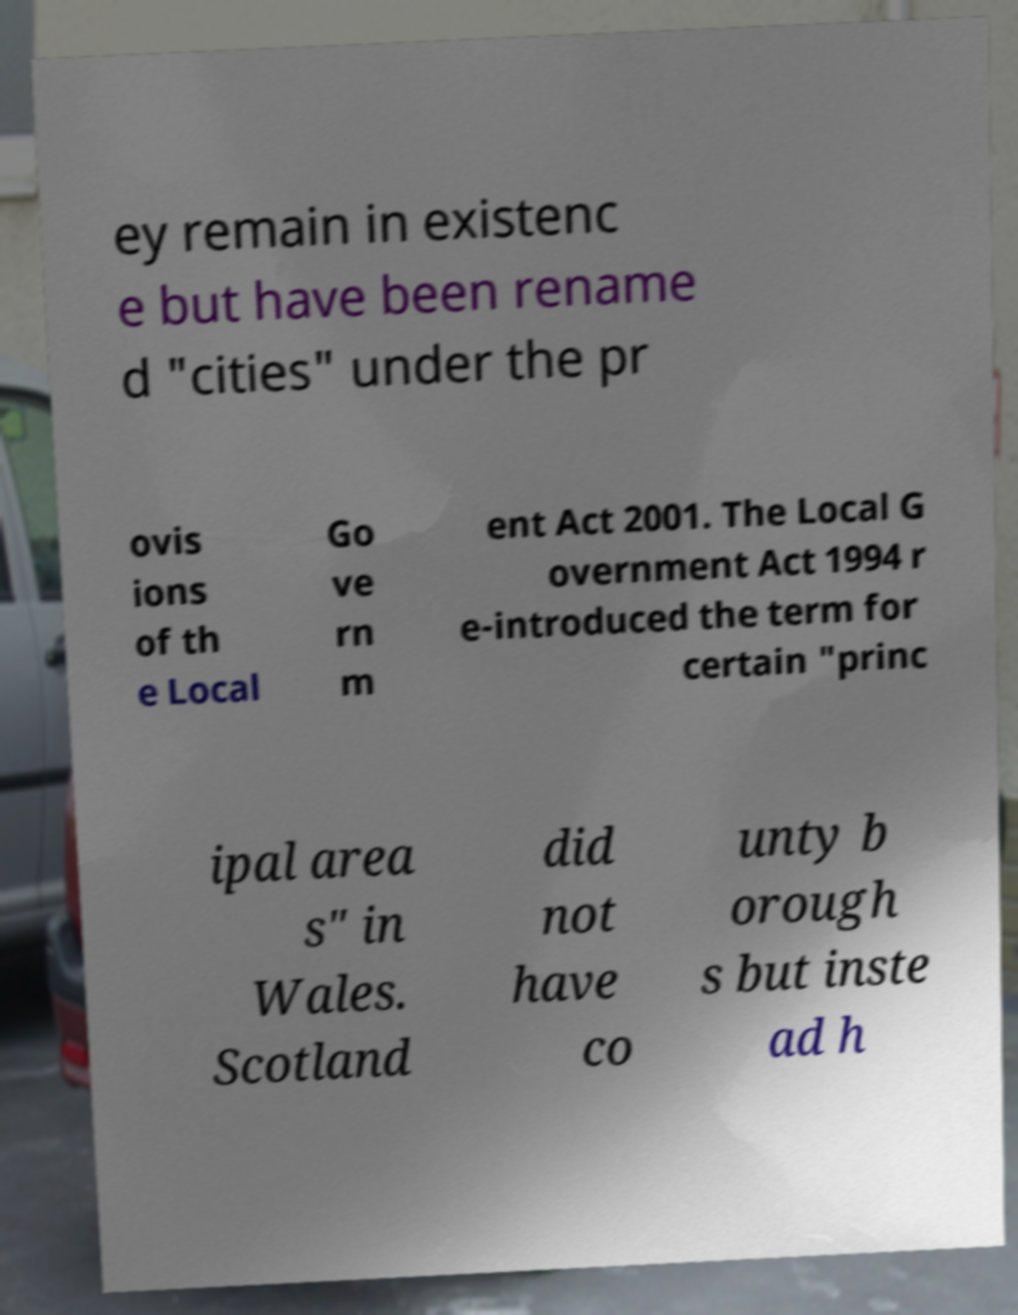Please identify and transcribe the text found in this image. ey remain in existenc e but have been rename d "cities" under the pr ovis ions of th e Local Go ve rn m ent Act 2001. The Local G overnment Act 1994 r e-introduced the term for certain "princ ipal area s" in Wales. Scotland did not have co unty b orough s but inste ad h 